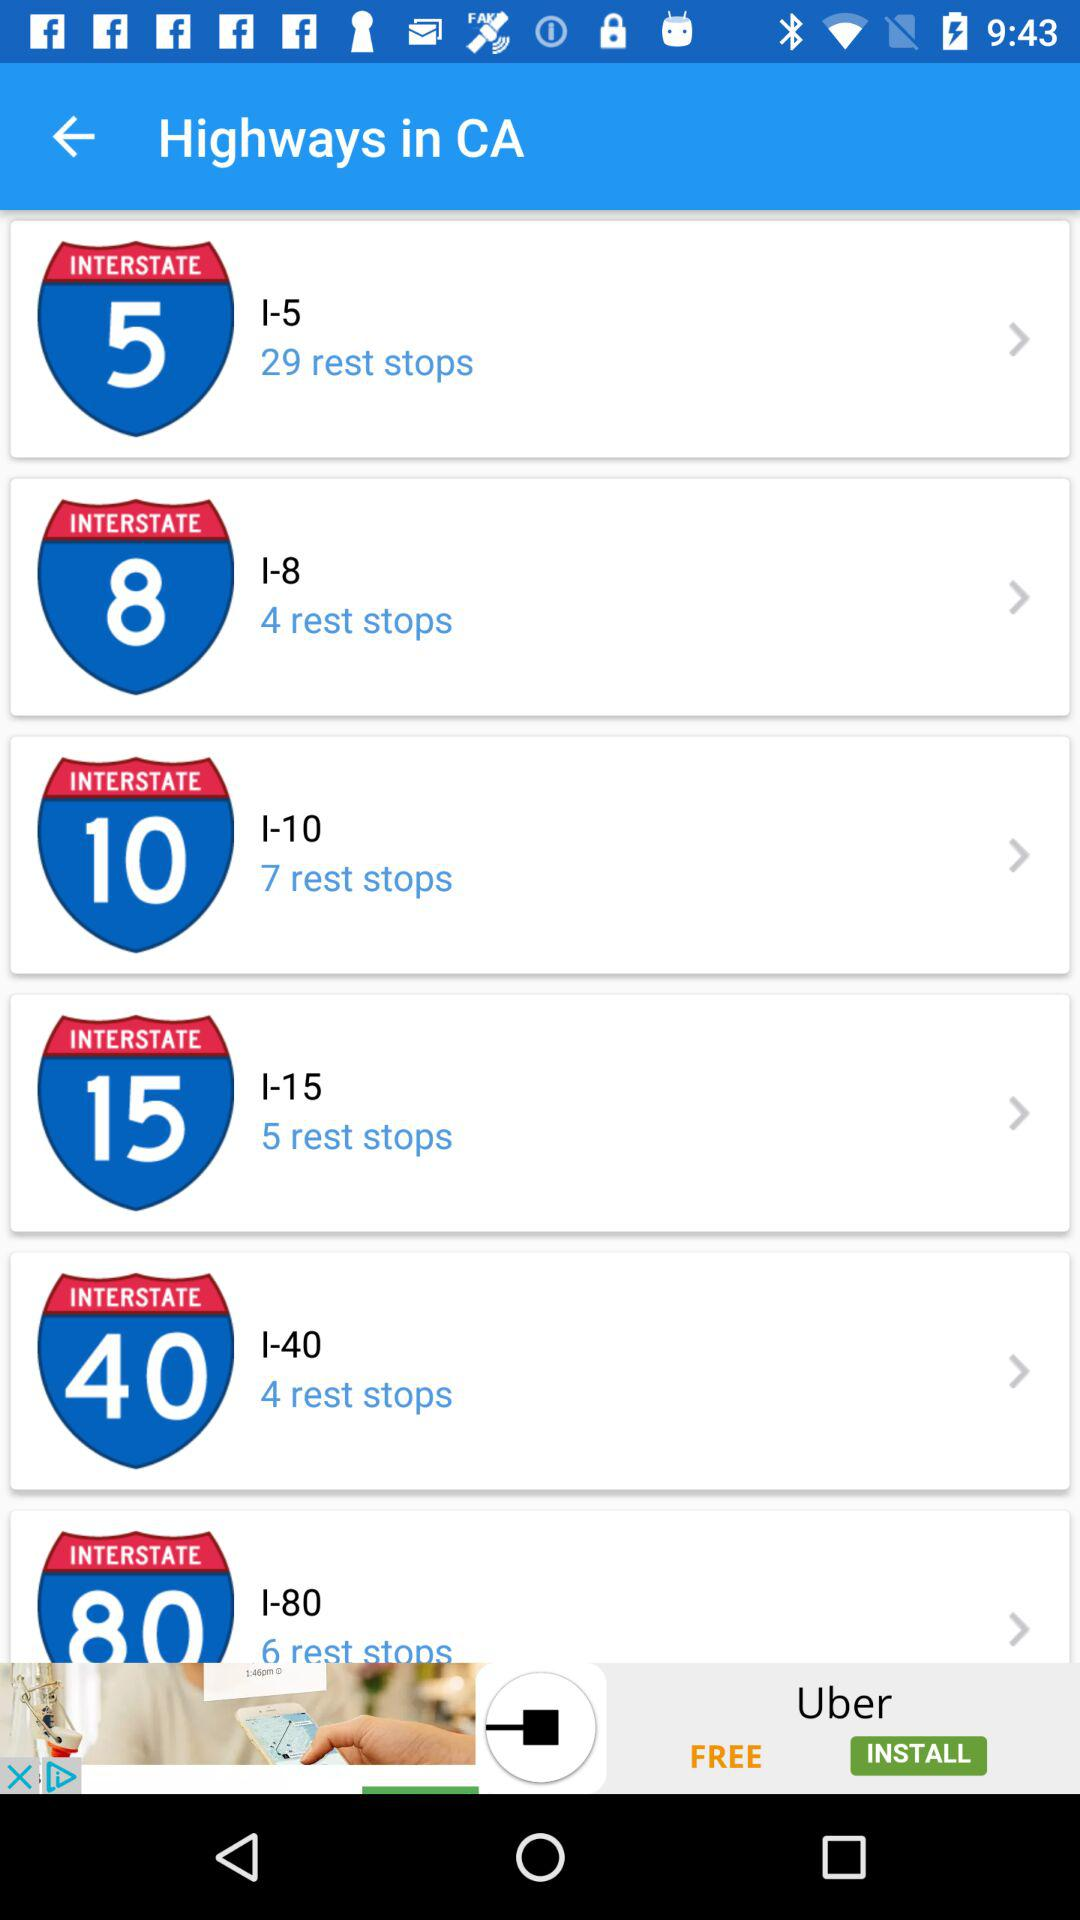What is the number of rest stops in "INTERSTATE 5"? The number of rest stops in "INTERSTATE 5" is 29. 